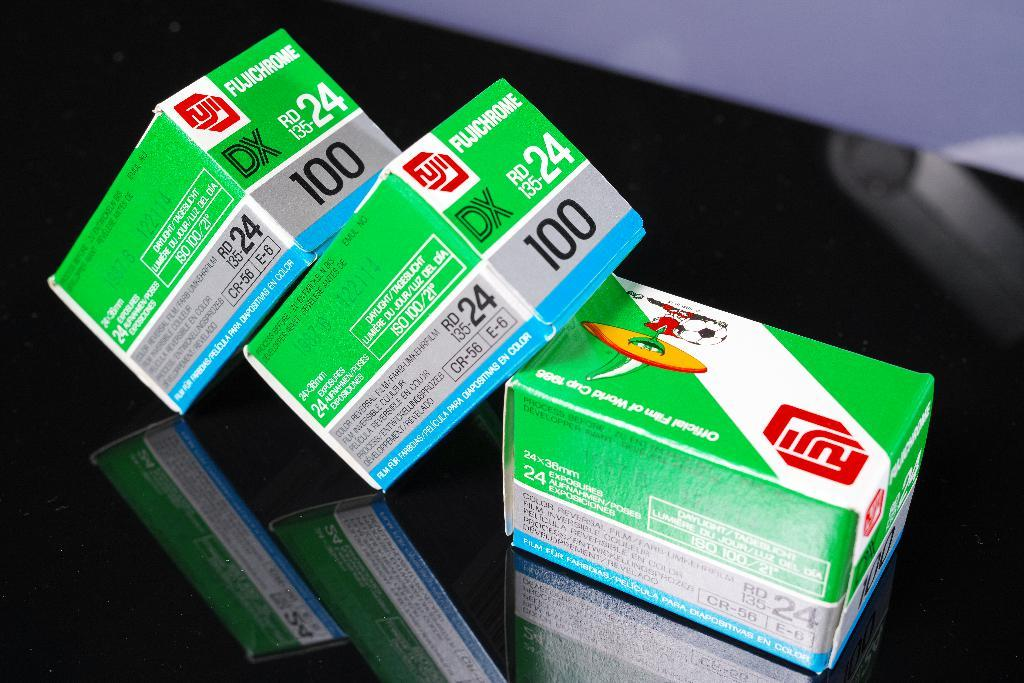<image>
Render a clear and concise summary of the photo. Fuji brand boxes have the number 100 on them. 